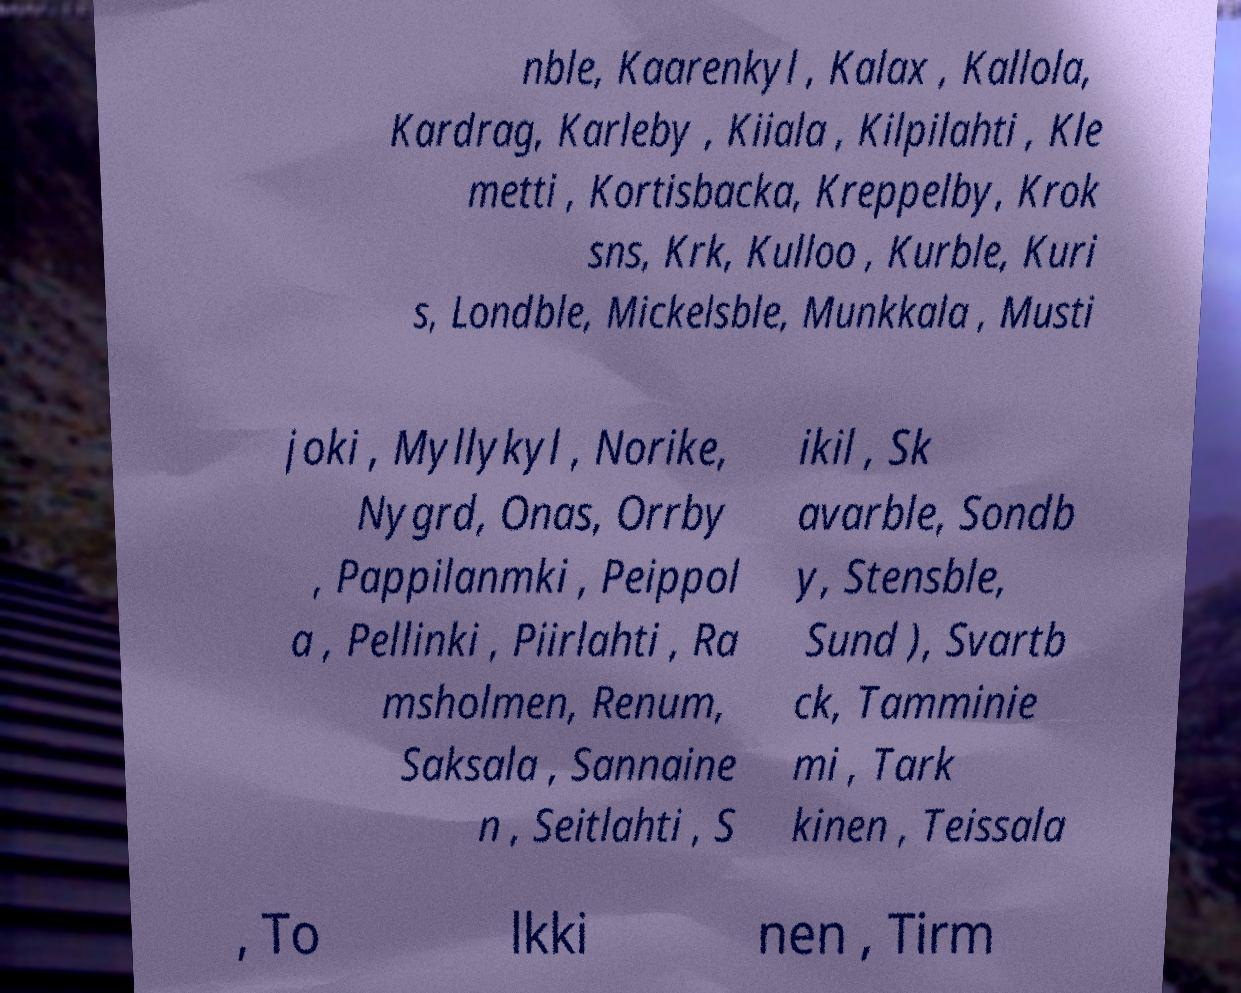Please identify and transcribe the text found in this image. nble, Kaarenkyl , Kalax , Kallola, Kardrag, Karleby , Kiiala , Kilpilahti , Kle metti , Kortisbacka, Kreppelby, Krok sns, Krk, Kulloo , Kurble, Kuri s, Londble, Mickelsble, Munkkala , Musti joki , Myllykyl , Norike, Nygrd, Onas, Orrby , Pappilanmki , Peippol a , Pellinki , Piirlahti , Ra msholmen, Renum, Saksala , Sannaine n , Seitlahti , S ikil , Sk avarble, Sondb y, Stensble, Sund ), Svartb ck, Tamminie mi , Tark kinen , Teissala , To lkki nen , Tirm 